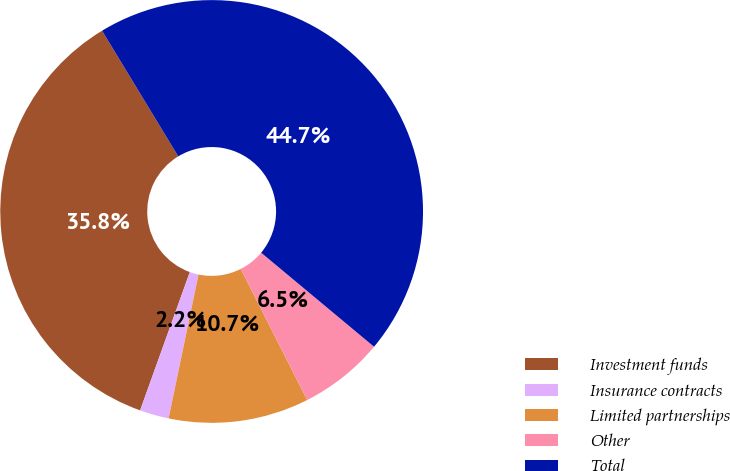Convert chart. <chart><loc_0><loc_0><loc_500><loc_500><pie_chart><fcel>Investment funds<fcel>Insurance contracts<fcel>Limited partnerships<fcel>Other<fcel>Total<nl><fcel>35.83%<fcel>2.23%<fcel>10.73%<fcel>6.48%<fcel>44.73%<nl></chart> 